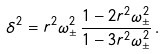Convert formula to latex. <formula><loc_0><loc_0><loc_500><loc_500>\delta ^ { 2 } = r ^ { 2 } \omega _ { \pm } ^ { 2 } \, \frac { 1 - 2 r ^ { 2 } \omega _ { \pm } ^ { 2 } } { 1 - 3 r ^ { 2 } \omega _ { \pm } ^ { 2 } } \, .</formula> 